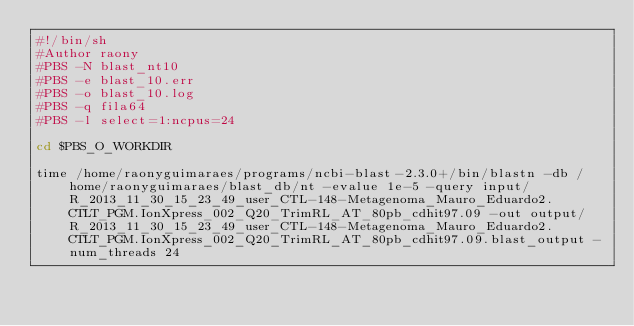Convert code to text. <code><loc_0><loc_0><loc_500><loc_500><_Bash_>#!/bin/sh
#Author raony
#PBS -N blast_nt10
#PBS -e blast_10.err
#PBS -o blast_10.log
#PBS -q fila64
#PBS -l select=1:ncpus=24

cd $PBS_O_WORKDIR

time /home/raonyguimaraes/programs/ncbi-blast-2.3.0+/bin/blastn -db /home/raonyguimaraes/blast_db/nt -evalue 1e-5 -query input/R_2013_11_30_15_23_49_user_CTL-148-Metagenoma_Mauro_Eduardo2.CTLT_PGM.IonXpress_002_Q20_TrimRL_AT_80pb_cdhit97.09 -out output/R_2013_11_30_15_23_49_user_CTL-148-Metagenoma_Mauro_Eduardo2.CTLT_PGM.IonXpress_002_Q20_TrimRL_AT_80pb_cdhit97.09.blast_output -num_threads 24</code> 